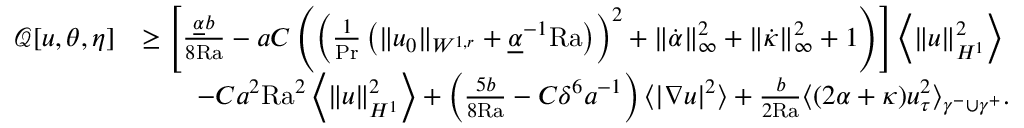Convert formula to latex. <formula><loc_0><loc_0><loc_500><loc_500>\begin{array} { r l } { \mathcal { Q } [ u , \theta , \eta ] } & { \geq \left [ \frac { \underline { \alpha } b } { 8 { R a } } - a C \left ( \left ( \frac { 1 } { P r } \left ( \| u _ { 0 } \| _ { W ^ { 1 , r } } + \underline { \alpha } ^ { - 1 } { R a } \right ) \right ) ^ { 2 } + \| \dot { \alpha } \| _ { \infty } ^ { 2 } + \| \dot { \kappa } \| _ { \infty } ^ { 2 } + 1 \right ) \right ] \left \langle \| u \| _ { H ^ { 1 } } ^ { 2 } \right \rangle } \\ & { \quad - C a ^ { 2 } { R a } ^ { 2 } \left \langle \| u \| _ { H ^ { 1 } } ^ { 2 } \right \rangle + \left ( \frac { 5 b } { 8 { R a } } - C \delta ^ { 6 } a ^ { - 1 } \right ) \langle | \nabla u | ^ { 2 } \rangle + \frac { b } { 2 { R a } } \langle ( 2 \alpha + \kappa ) u _ { \tau } ^ { 2 } \rangle _ { \gamma ^ { - } \cup \gamma ^ { + } } . } \end{array}</formula> 